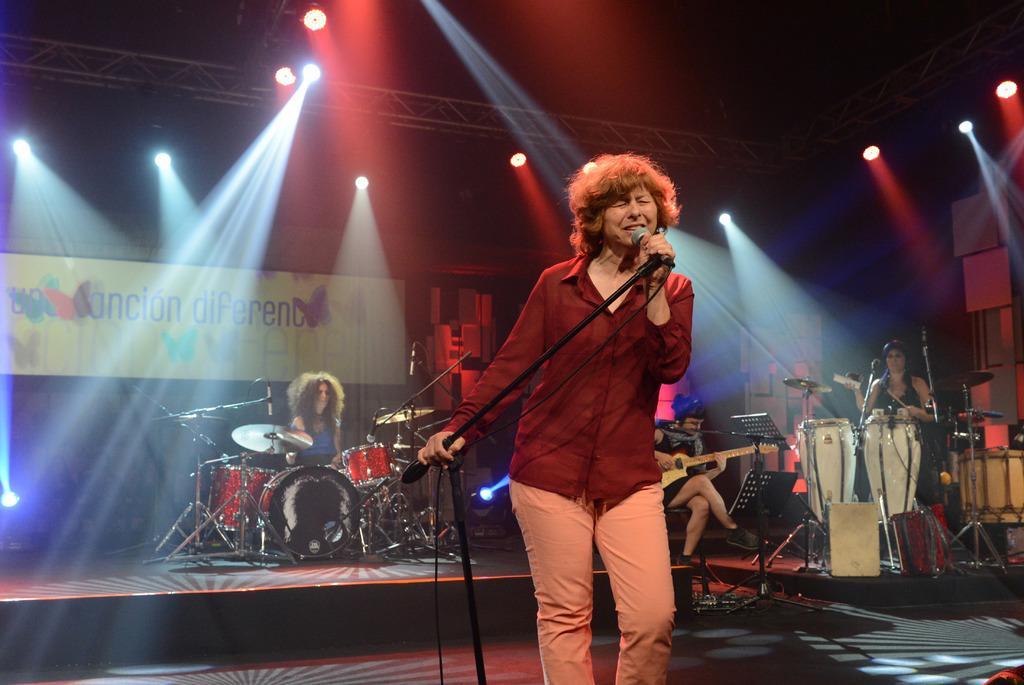Can you describe this image briefly? In this image, in the middle there is a person standing and holding a microphone which is in microphone which is in black color and singing in the microphones, in the background there are some people sitting and holding the music instruments, in the left side there are some music instruments which are in red color and there is a person sitting and playing the music instruments, there are some lights which are in red and green color and there is a poster which is in yellow color. 